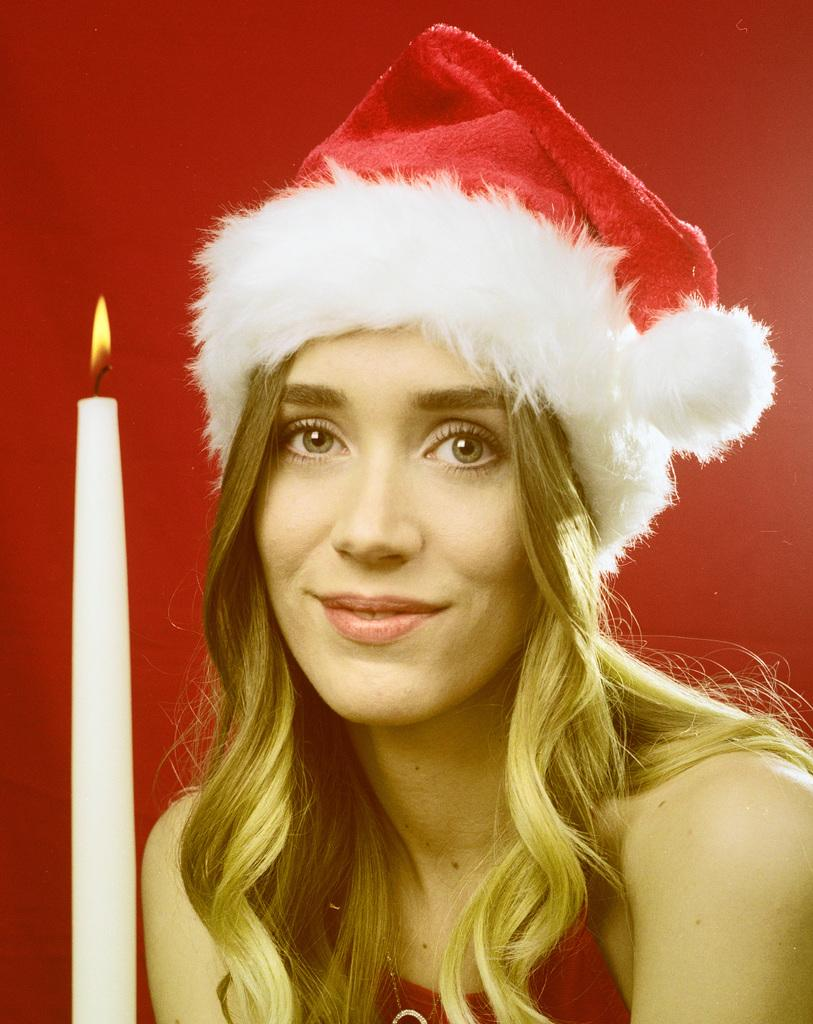Who is present in the image? There is a woman in the image. What is the woman wearing on her head? The woman is wearing a cap. What object can be seen on the left side of the image? There is a candle on the left side of the image. What color is the background of the image? The background of the image is red. How many rabbits can be seen talking and smiling in the image? There are no rabbits present in the image, and rabbits cannot talk or smile. 